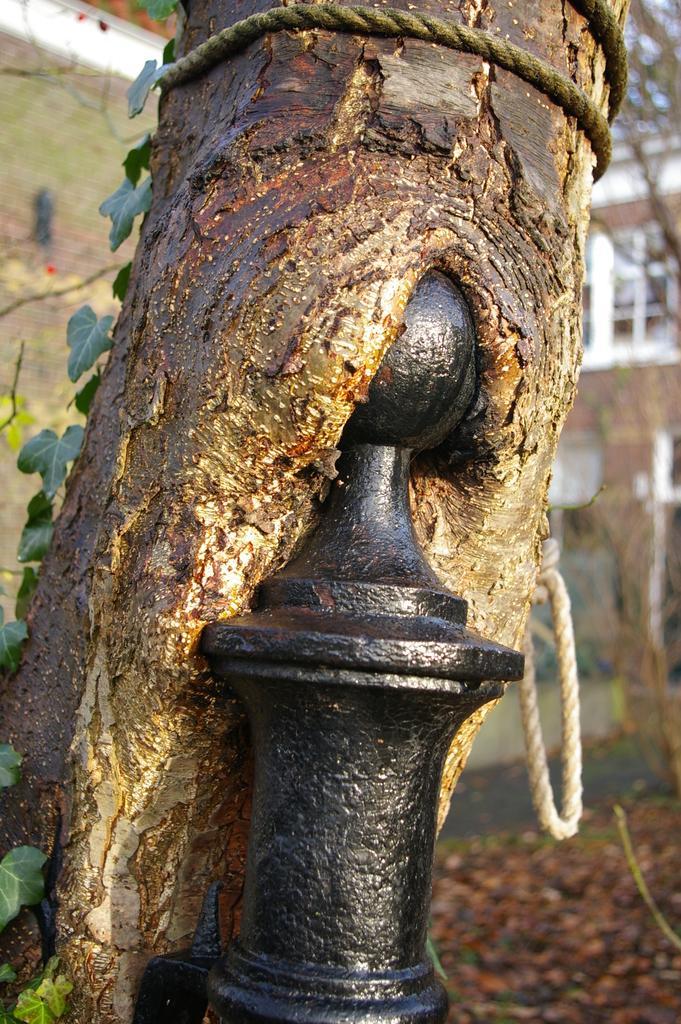Describe this image in one or two sentences. In the image in the center we can see pole,tree and rope. In the background there is a building,wall and window. 